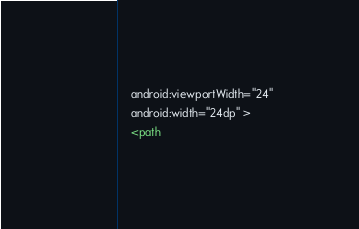Convert code to text. <code><loc_0><loc_0><loc_500><loc_500><_XML_>    android:viewportWidth="24"
    android:width="24dp" >
    <path</code> 